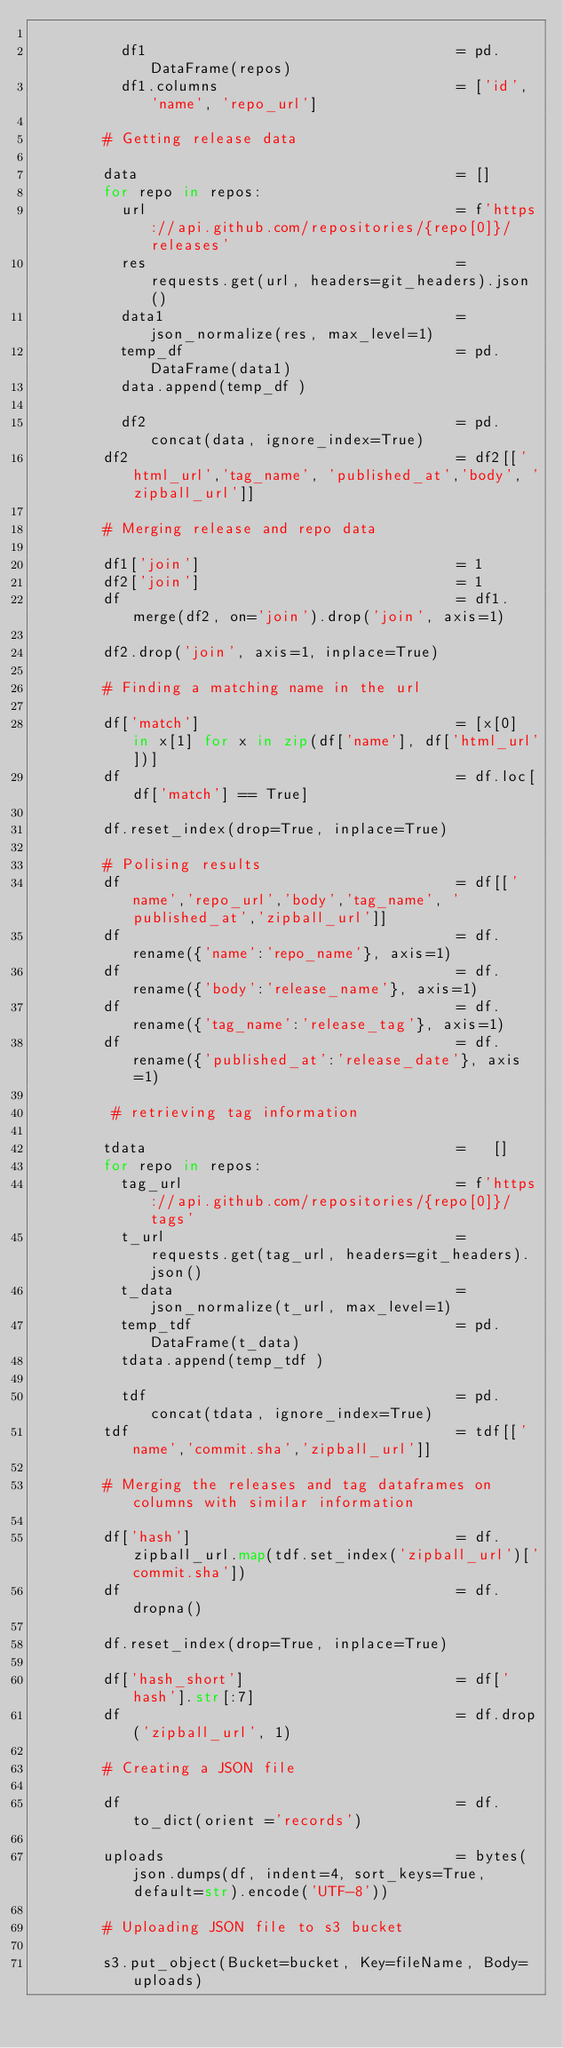Convert code to text. <code><loc_0><loc_0><loc_500><loc_500><_Python_>
          df1                                   = pd.DataFrame(repos)
          df1.columns                           = ['id', 'name', 'repo_url']

        # Getting release data

        data                                    = []
        for repo in repos:
          url                                   = f'https://api.github.com/repositories/{repo[0]}/releases'
          res                                   = requests.get(url, headers=git_headers).json()
          data1                                 = json_normalize(res, max_level=1)
          temp_df                               = pd.DataFrame(data1)
          data.append(temp_df )

          df2                                   = pd.concat(data, ignore_index=True)
        df2                                     = df2[['html_url','tag_name', 'published_at','body', 'zipball_url']]

        # Merging release and repo data

        df1['join']                             = 1
        df2['join']                             = 1
        df                                      = df1.merge(df2, on='join').drop('join', axis=1)

        df2.drop('join', axis=1, inplace=True)

        # Finding a matching name in the url

        df['match']                             = [x[0] in x[1] for x in zip(df['name'], df['html_url'])]
        df                                      = df.loc[df['match'] == True]

        df.reset_index(drop=True, inplace=True)

        # Polising results
        df                                      = df[['name','repo_url','body','tag_name', 'published_at','zipball_url']]
        df                                      = df.rename({'name':'repo_name'}, axis=1)
        df                                      = df.rename({'body':'release_name'}, axis=1)
        df                                      = df.rename({'tag_name':'release_tag'}, axis=1)
        df                                      = df.rename({'published_at':'release_date'}, axis=1)

         # retrieving tag information

        tdata                                   =   []
        for repo in repos:
          tag_url                               = f'https://api.github.com/repositories/{repo[0]}/tags'
          t_url                                 = requests.get(tag_url, headers=git_headers).json()
          t_data                                = json_normalize(t_url, max_level=1)
          temp_tdf                              = pd.DataFrame(t_data)
          tdata.append(temp_tdf )

          tdf                                   = pd.concat(tdata, ignore_index=True)
        tdf                                     = tdf[['name','commit.sha','zipball_url']]

        # Merging the releases and tag dataframes on columns with similar information

        df['hash']                              = df.zipball_url.map(tdf.set_index('zipball_url')['commit.sha'])
        df                                      = df.dropna()

        df.reset_index(drop=True, inplace=True)

        df['hash_short']                        = df['hash'].str[:7]
        df                                      = df.drop('zipball_url', 1)

        # Creating a JSON file

        df                                      = df.to_dict(orient ='records')

        uploads                                 = bytes(json.dumps(df, indent=4, sort_keys=True, default=str).encode('UTF-8'))

        # Uploading JSON file to s3 bucket

        s3.put_object(Bucket=bucket, Key=fileName, Body=uploads)
</code> 